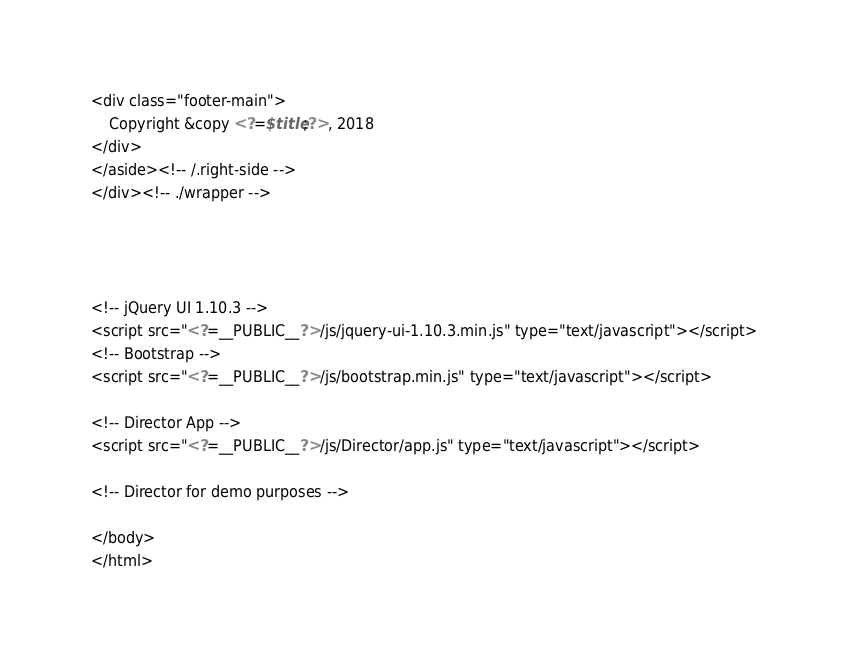<code> <loc_0><loc_0><loc_500><loc_500><_PHP_>
<div class="footer-main">
    Copyright &copy <?=$title;?>, 2018
</div>
</aside><!-- /.right-side -->
</div><!-- ./wrapper -->




<!-- jQuery UI 1.10.3 -->
<script src="<?=__PUBLIC__?>/js/jquery-ui-1.10.3.min.js" type="text/javascript"></script>
<!-- Bootstrap -->
<script src="<?=__PUBLIC__?>/js/bootstrap.min.js" type="text/javascript"></script>

<!-- Director App -->
<script src="<?=__PUBLIC__?>/js/Director/app.js" type="text/javascript"></script>

<!-- Director for demo purposes -->

</body>
</html></code> 